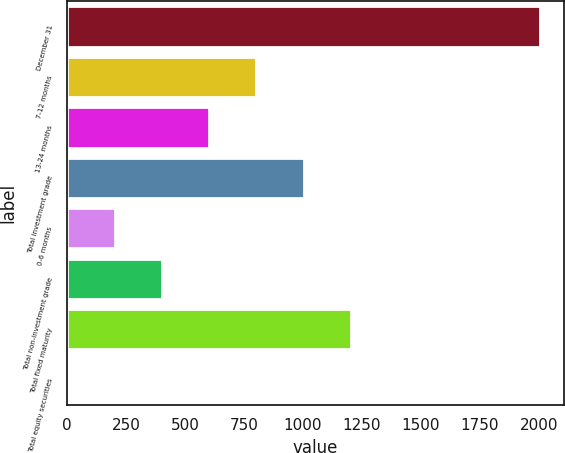Convert chart. <chart><loc_0><loc_0><loc_500><loc_500><bar_chart><fcel>December 31<fcel>7-12 months<fcel>13-24 months<fcel>Total investment grade<fcel>0-6 months<fcel>Total non-investment grade<fcel>Total fixed maturity<fcel>Total equity securities<nl><fcel>2005<fcel>803.2<fcel>602.9<fcel>1003.5<fcel>202.3<fcel>402.6<fcel>1203.8<fcel>2<nl></chart> 